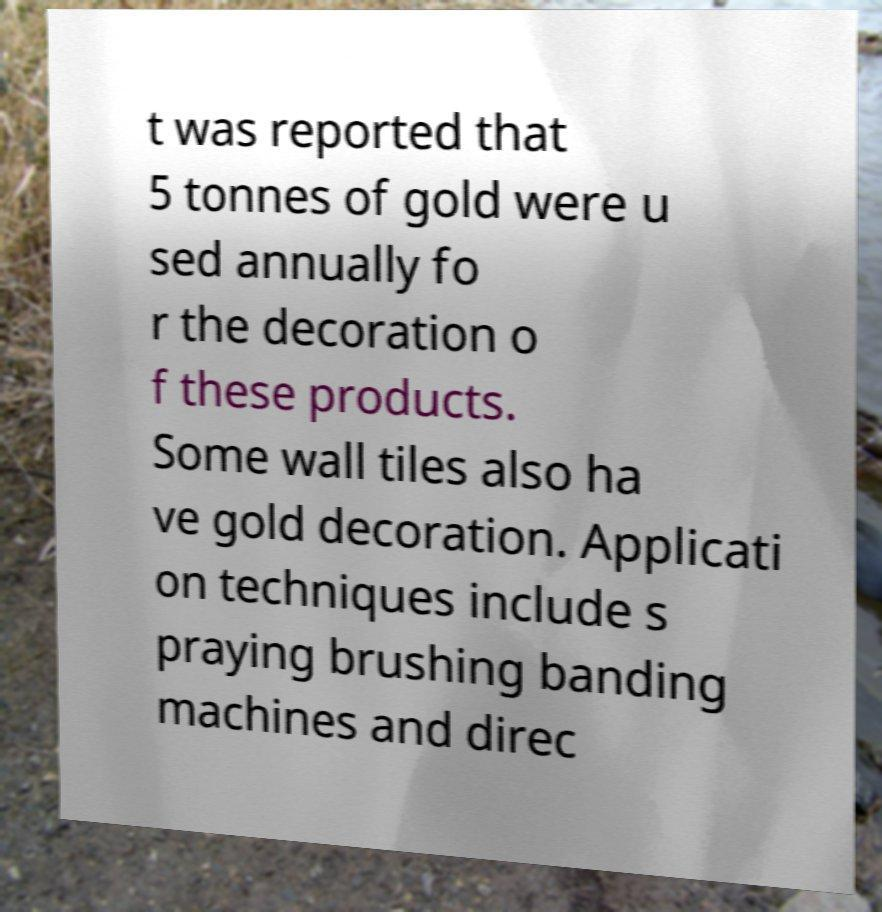What messages or text are displayed in this image? I need them in a readable, typed format. t was reported that 5 tonnes of gold were u sed annually fo r the decoration o f these products. Some wall tiles also ha ve gold decoration. Applicati on techniques include s praying brushing banding machines and direc 